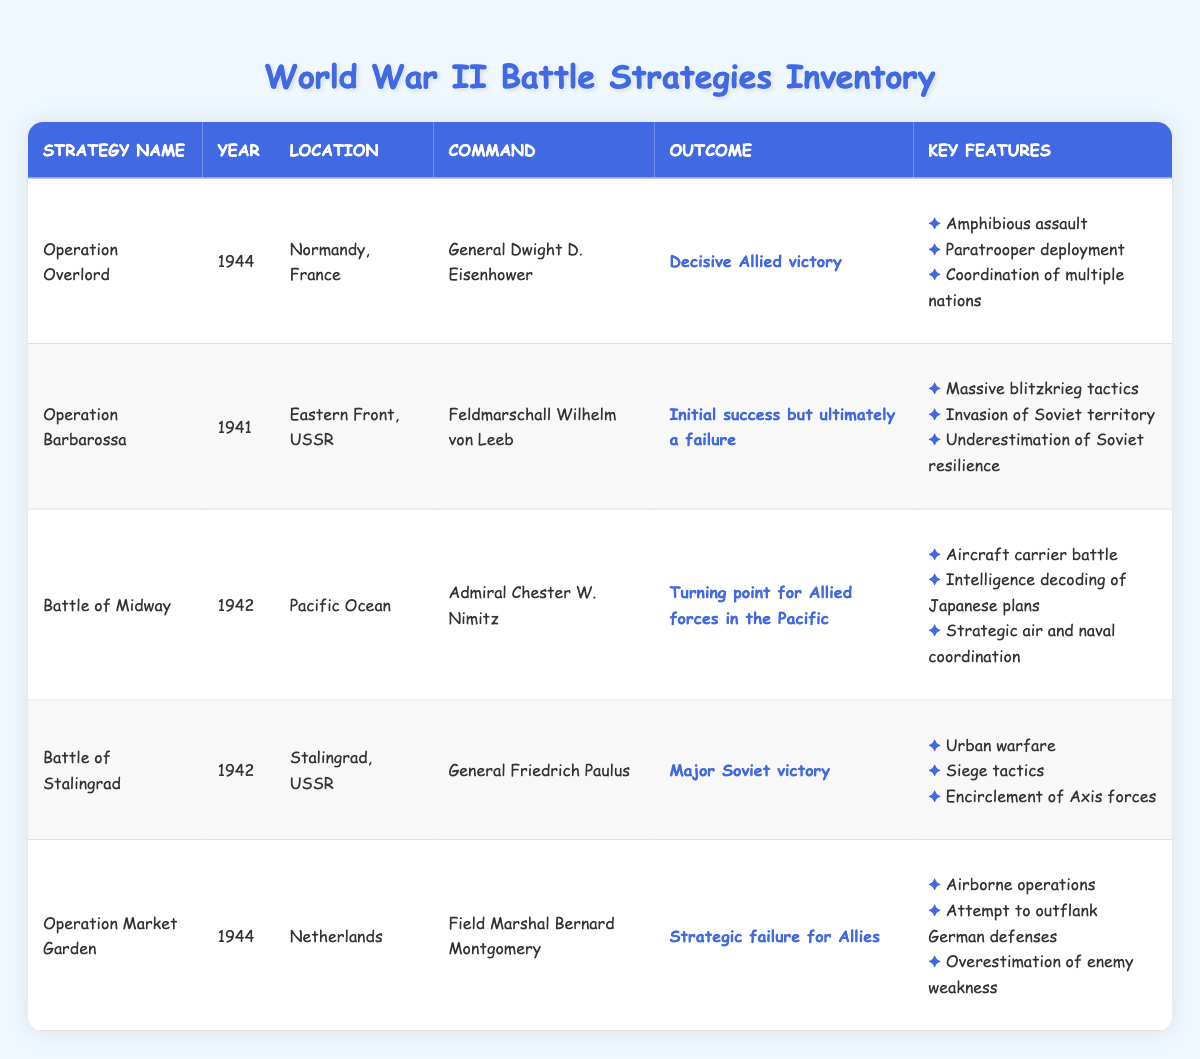What was the outcome of Operation Overlord? The outcome of Operation Overlord is mentioned in the table under the "Outcome" column for this strategy, which states "Decisive Allied victory."
Answer: Decisive Allied victory In which year did the Battle of Stalingrad occur? The year for the Battle of Stalingrad is stated in the "Year" column of the table, which shows 1942.
Answer: 1942 How many battle strategies listed had outcomes classified as "failure" or "strategic failure"? By reviewing the "Outcome" column, I see two strategies with outcomes that indicate a failure: "Operation Barbarossa" and "Operation Market Garden."
Answer: 2 Which strategy had the key feature of "Intelligence decoding of Japanese plans"? This key feature is found under the "Key Features" of the "Battle of Midway" in the table, confirming that it is associated with this strategy.
Answer: Battle of Midway Is it true that every battle strategy listed was led by a military general? Checking the "Command" column, I note that both "Operation Overlord" and "Battle of Midway" had commanders holding high ranks but "Operation Market Garden" has a Field Marshal. Thus, while most were led by generals, some were not, making the statement false.
Answer: No Which strategy was executed in 1944 and was a strategic failure? In reviewing the "Year" column, I find that "Operation Market Garden" is the strategy from 1944 that is categorized under the "Outcome" as a strategic failure.
Answer: Operation Market Garden What were the years of the battles that occurred on the Eastern Front? The table shows that "Operation Barbarossa" and "Battle of Stalingrad" both took place in the year 1942, thus the years are 1941 for Operation Barbarossa and 1942 for Battle of Stalingrad.
Answer: 1941 and 1942 How many strategies used airborne operations as a key feature? Referring to the "Key Features" column, only "Operation Market Garden" includes airborne operations, confirming that only one strategy had this as a feature.
Answer: 1 Which battle strategy involved the coordination of multiple nations? This detail can be found in the "Key Features" of "Operation Overlord," indicating that it included the coordination of multiple nations as a significant feature.
Answer: Operation Overlord 